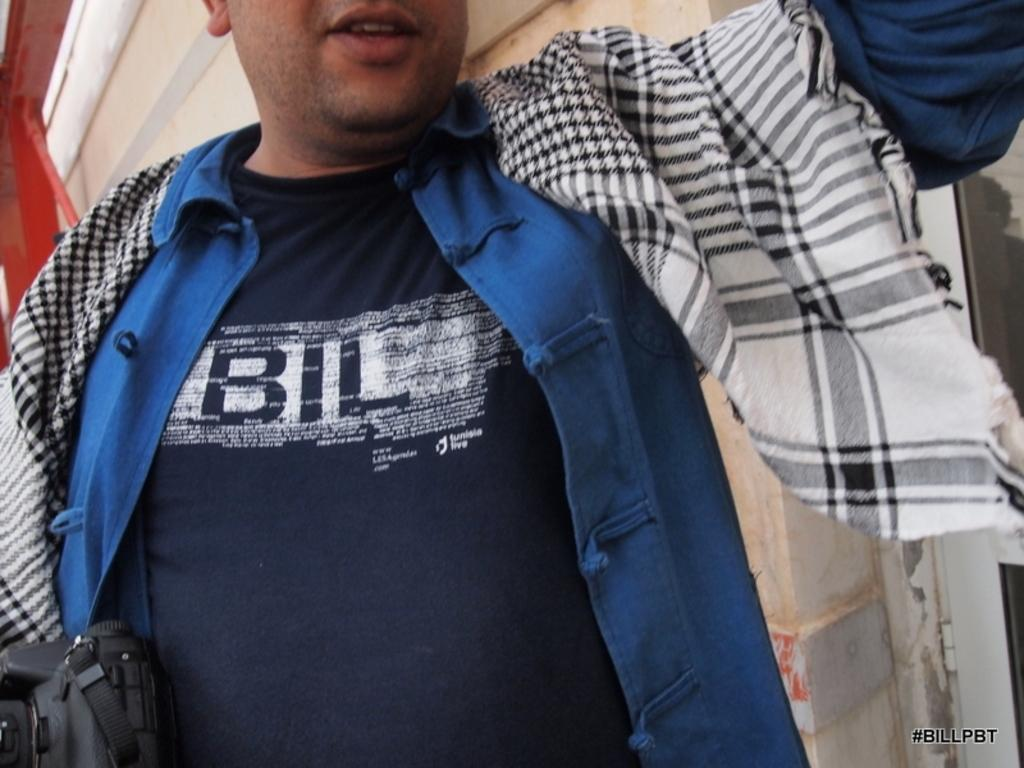What is the main subject of the image? There is a man in the image. What is the man holding in the image? The man is holding a camera. Can you describe the man's facial features in the image? The man's face is partially visible in the image. What is located behind the man in the image? There is a wall behind the man. What type of rat can be seen climbing the wall in the image? There is no rat present in the image; it only features a man holding a camera with a wall in the background. 